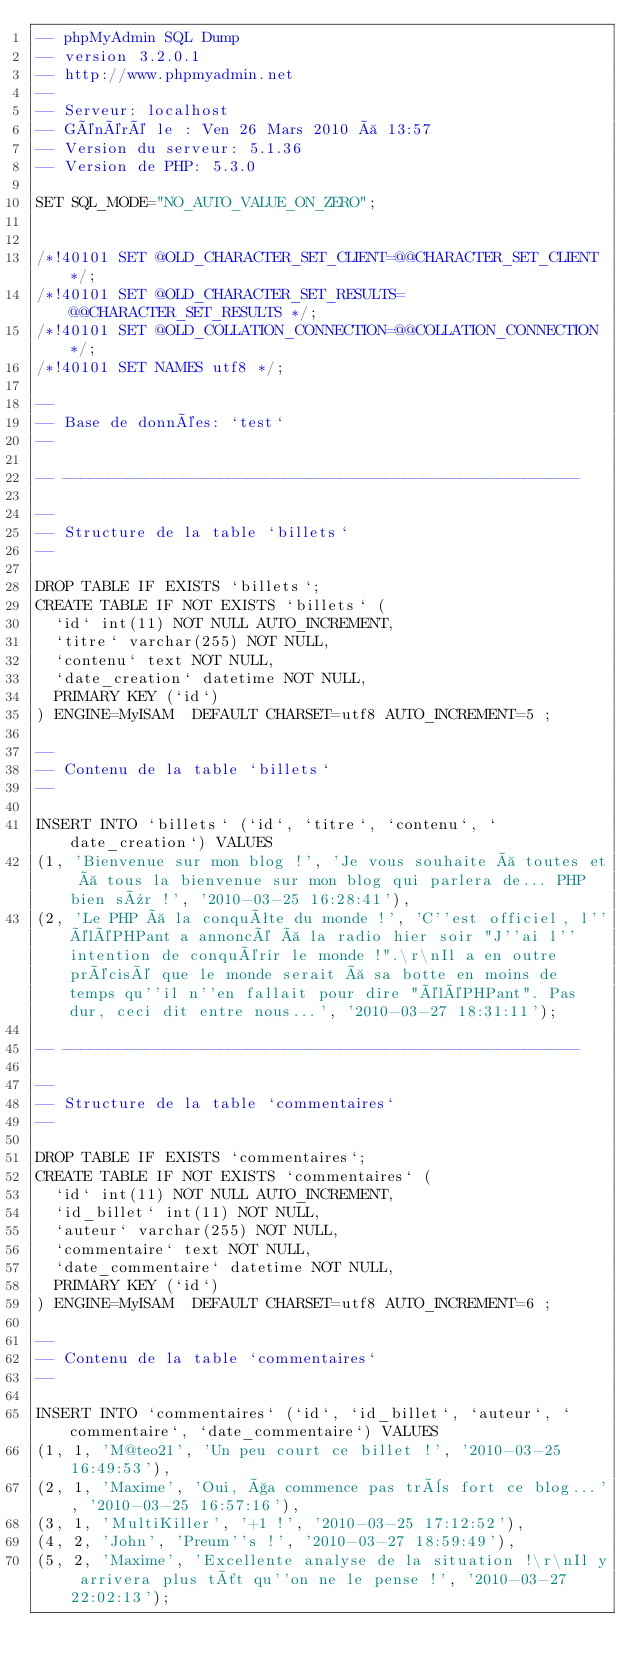Convert code to text. <code><loc_0><loc_0><loc_500><loc_500><_SQL_>-- phpMyAdmin SQL Dump
-- version 3.2.0.1
-- http://www.phpmyadmin.net
--
-- Serveur: localhost
-- Généré le : Ven 26 Mars 2010 à 13:57
-- Version du serveur: 5.1.36
-- Version de PHP: 5.3.0

SET SQL_MODE="NO_AUTO_VALUE_ON_ZERO";


/*!40101 SET @OLD_CHARACTER_SET_CLIENT=@@CHARACTER_SET_CLIENT */;
/*!40101 SET @OLD_CHARACTER_SET_RESULTS=@@CHARACTER_SET_RESULTS */;
/*!40101 SET @OLD_COLLATION_CONNECTION=@@COLLATION_CONNECTION */;
/*!40101 SET NAMES utf8 */;

--
-- Base de données: `test`
--

-- --------------------------------------------------------

--
-- Structure de la table `billets`
--

DROP TABLE IF EXISTS `billets`;
CREATE TABLE IF NOT EXISTS `billets` (
  `id` int(11) NOT NULL AUTO_INCREMENT,
  `titre` varchar(255) NOT NULL,
  `contenu` text NOT NULL,
  `date_creation` datetime NOT NULL,
  PRIMARY KEY (`id`)
) ENGINE=MyISAM  DEFAULT CHARSET=utf8 AUTO_INCREMENT=5 ;

--
-- Contenu de la table `billets`
--

INSERT INTO `billets` (`id`, `titre`, `contenu`, `date_creation`) VALUES
(1, 'Bienvenue sur mon blog !', 'Je vous souhaite à toutes et à tous la bienvenue sur mon blog qui parlera de... PHP bien sûr !', '2010-03-25 16:28:41'),
(2, 'Le PHP à la conquête du monde !', 'C''est officiel, l''éléPHPant a annoncé à la radio hier soir "J''ai l''intention de conquérir le monde !".\r\nIl a en outre précisé que le monde serait à sa botte en moins de temps qu''il n''en fallait pour dire "éléPHPant". Pas dur, ceci dit entre nous...', '2010-03-27 18:31:11');

-- --------------------------------------------------------

--
-- Structure de la table `commentaires`
--

DROP TABLE IF EXISTS `commentaires`;
CREATE TABLE IF NOT EXISTS `commentaires` (
  `id` int(11) NOT NULL AUTO_INCREMENT,
  `id_billet` int(11) NOT NULL,
  `auteur` varchar(255) NOT NULL,
  `commentaire` text NOT NULL,
  `date_commentaire` datetime NOT NULL,
  PRIMARY KEY (`id`)
) ENGINE=MyISAM  DEFAULT CHARSET=utf8 AUTO_INCREMENT=6 ;

--
-- Contenu de la table `commentaires`
--

INSERT INTO `commentaires` (`id`, `id_billet`, `auteur`, `commentaire`, `date_commentaire`) VALUES
(1, 1, 'M@teo21', 'Un peu court ce billet !', '2010-03-25 16:49:53'),
(2, 1, 'Maxime', 'Oui, ça commence pas très fort ce blog...', '2010-03-25 16:57:16'),
(3, 1, 'MultiKiller', '+1 !', '2010-03-25 17:12:52'),
(4, 2, 'John', 'Preum''s !', '2010-03-27 18:59:49'),
(5, 2, 'Maxime', 'Excellente analyse de la situation !\r\nIl y arrivera plus tôt qu''on ne le pense !', '2010-03-27 22:02:13');
</code> 